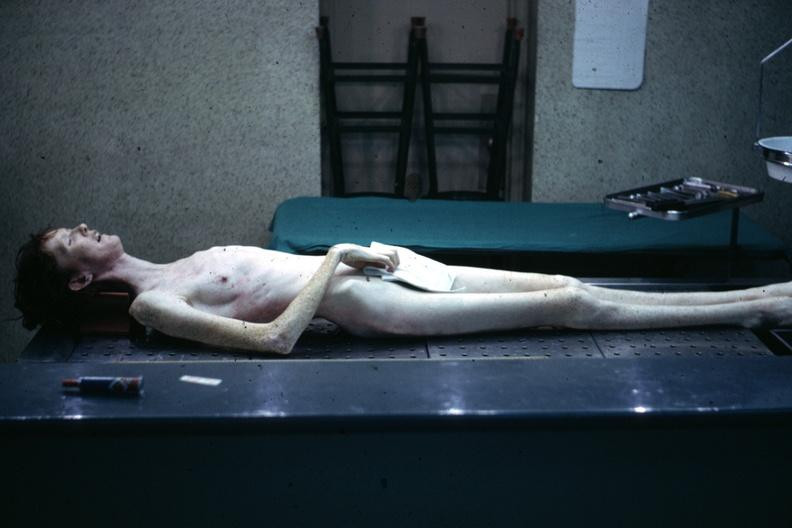s marfans syndrome present?
Answer the question using a single word or phrase. Yes 